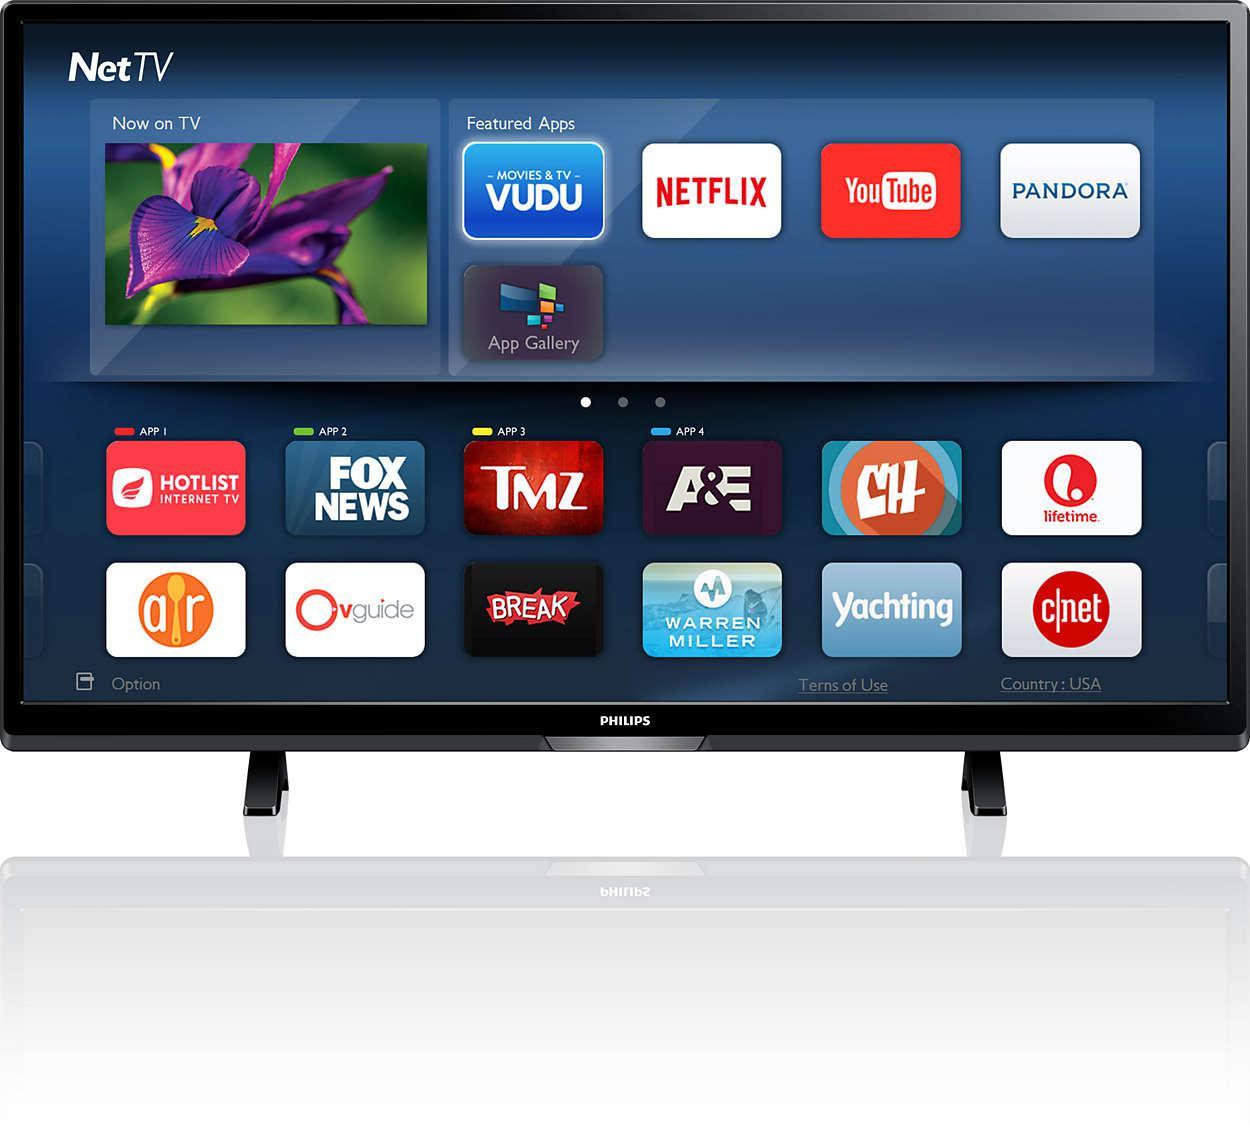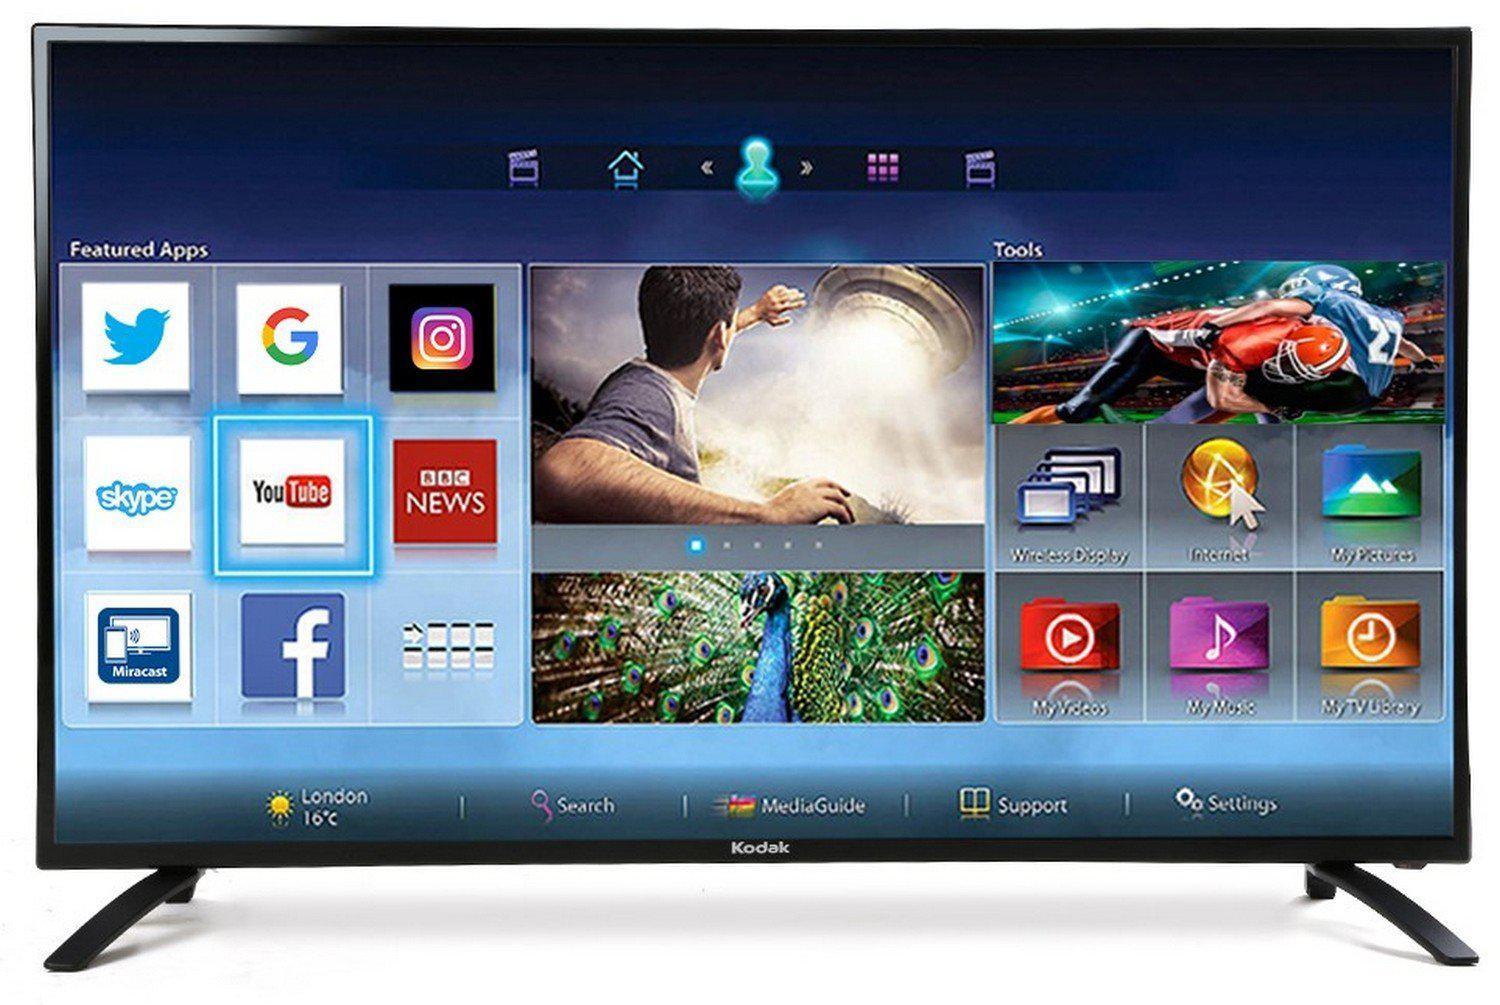The first image is the image on the left, the second image is the image on the right. Considering the images on both sides, is "There are apps displayed on the television." valid? Answer yes or no. Yes. The first image is the image on the left, the second image is the image on the right. Given the left and right images, does the statement "At least one television has two legs." hold true? Answer yes or no. Yes. 